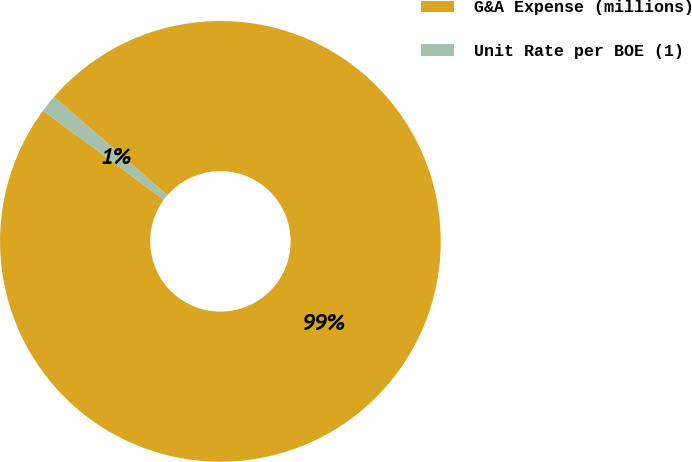Convert chart. <chart><loc_0><loc_0><loc_500><loc_500><pie_chart><fcel>G&A Expense (millions)<fcel>Unit Rate per BOE (1)<nl><fcel>98.73%<fcel>1.27%<nl></chart> 